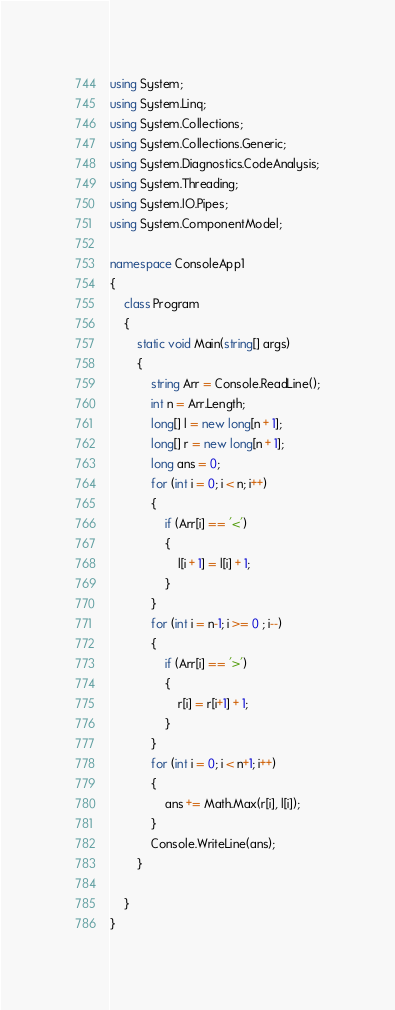Convert code to text. <code><loc_0><loc_0><loc_500><loc_500><_C#_>using System;
using System.Linq;
using System.Collections;
using System.Collections.Generic;
using System.Diagnostics.CodeAnalysis;
using System.Threading;
using System.IO.Pipes;
using System.ComponentModel;

namespace ConsoleApp1
{
    class Program
    {
        static void Main(string[] args)
        {
            string Arr = Console.ReadLine();
            int n = Arr.Length;
            long[] l = new long[n + 1];
            long[] r = new long[n + 1];
            long ans = 0;
            for (int i = 0; i < n; i++) 
            {
                if (Arr[i] == '<') 
                {
                    l[i + 1] = l[i] + 1;
                }
            }
            for (int i = n-1; i >= 0 ; i--)
            {
                if (Arr[i] == '>')
                {
                    r[i] = r[i+1] + 1;
                }
            }
            for (int i = 0; i < n+1; i++)
            {
                ans += Math.Max(r[i], l[i]);
            }
            Console.WriteLine(ans);
        }

    }
}
</code> 